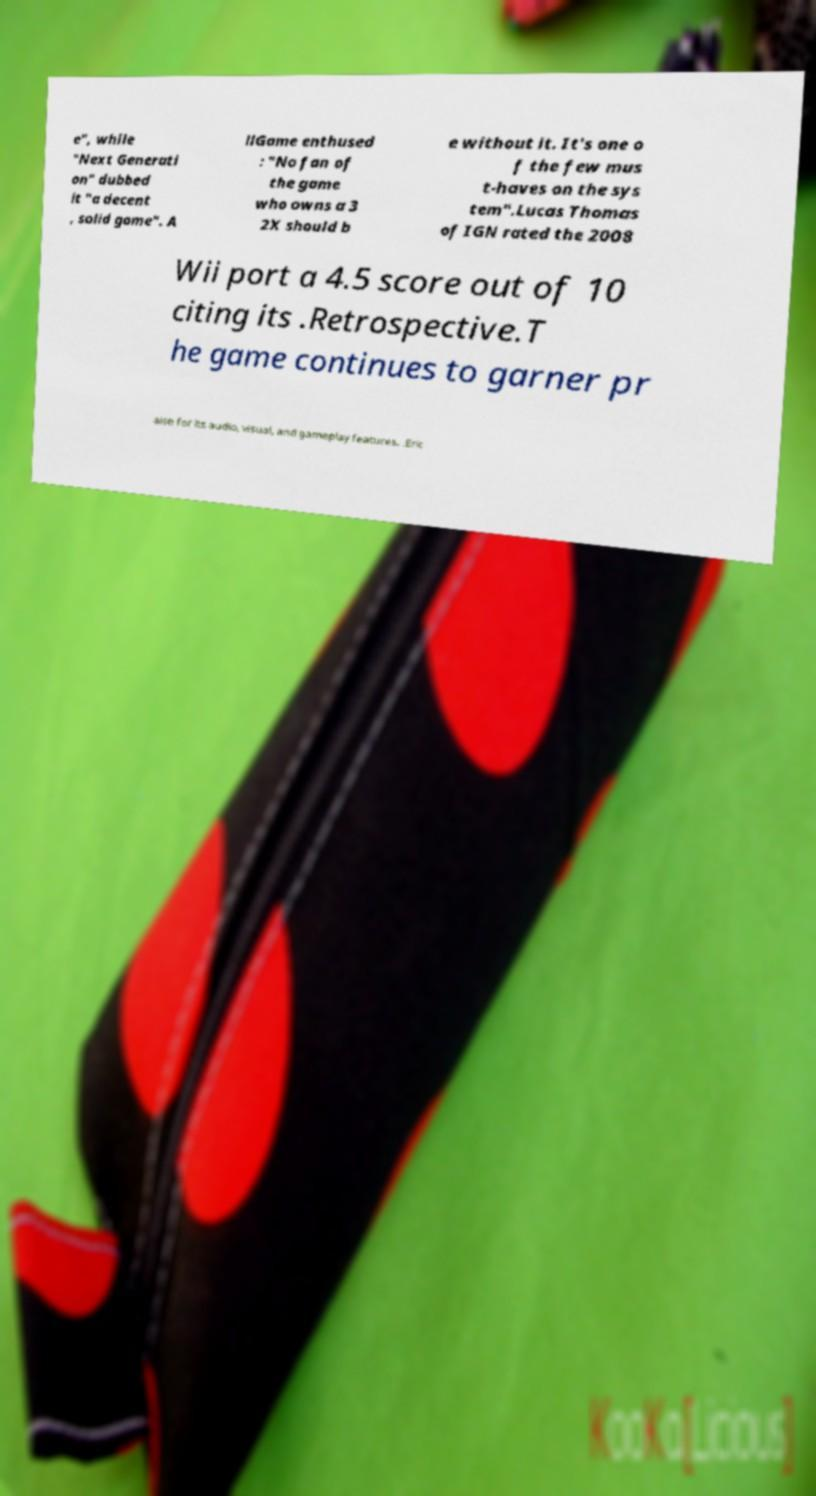For documentation purposes, I need the text within this image transcribed. Could you provide that? e", while "Next Generati on" dubbed it "a decent , solid game". A llGame enthused : "No fan of the game who owns a 3 2X should b e without it. It's one o f the few mus t-haves on the sys tem".Lucas Thomas of IGN rated the 2008 Wii port a 4.5 score out of 10 citing its .Retrospective.T he game continues to garner pr aise for its audio, visual, and gameplay features. .Eric 